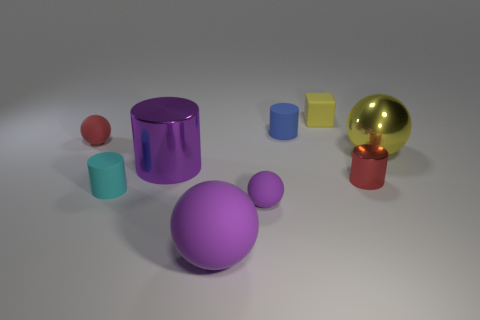How many things are either large purple cylinders or tiny matte things behind the tiny blue matte cylinder?
Keep it short and to the point. 2. Is there a tiny yellow rubber object that has the same shape as the big yellow thing?
Provide a succinct answer. No. What size is the red matte thing that is behind the big metal thing that is to the right of the large purple sphere?
Offer a terse response. Small. Do the big matte ball and the metallic sphere have the same color?
Make the answer very short. No. What number of matte objects are either tiny yellow objects or tiny balls?
Offer a terse response. 3. What number of gray cylinders are there?
Give a very brief answer. 0. Are the red object that is on the right side of the big purple shiny cylinder and the cylinder that is behind the small red matte ball made of the same material?
Your response must be concise. No. There is a small metal thing that is the same shape as the blue matte object; what color is it?
Make the answer very short. Red. What is the material of the small sphere in front of the large sphere behind the cyan object?
Your answer should be very brief. Rubber. There is a metal object that is to the left of the small yellow block; does it have the same shape as the red thing that is on the right side of the big purple sphere?
Provide a short and direct response. Yes. 